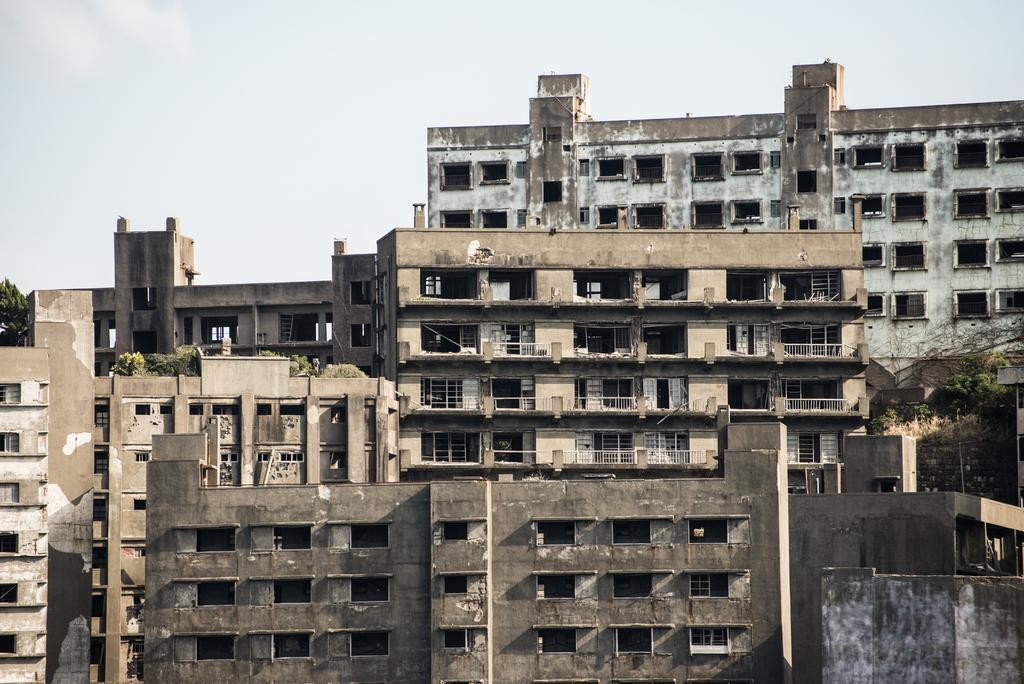What type of structures can be seen in the image? There are buildings in the image. What other natural elements are present in the image? There are trees in the image. How would you describe the weather based on the image? The sky is sunny in the image. Where is the coastline visible in the image? There is no coastline present in the image; it features buildings and trees. What type of ball is being used in the baseball game in the image? There is no baseball game or ball present in the image. 